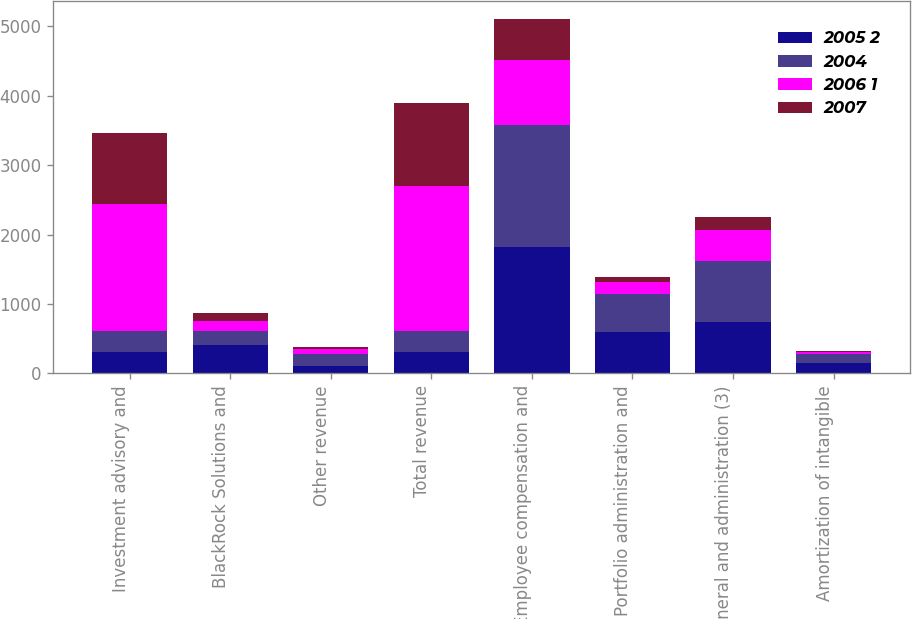Convert chart. <chart><loc_0><loc_0><loc_500><loc_500><stacked_bar_chart><ecel><fcel>Investment advisory and<fcel>BlackRock Solutions and<fcel>Other revenue<fcel>Total revenue<fcel>Employee compensation and<fcel>Portfolio administration and<fcel>General and administration (3)<fcel>Amortization of intangible<nl><fcel>2005 2<fcel>302<fcel>406<fcel>110<fcel>302<fcel>1815<fcel>597<fcel>745<fcel>146<nl><fcel>2004<fcel>302<fcel>198<fcel>164<fcel>302<fcel>1767<fcel>548<fcel>870<fcel>130<nl><fcel>2006 1<fcel>1841<fcel>148<fcel>73<fcel>2098<fcel>934<fcel>173<fcel>451<fcel>38<nl><fcel>2007<fcel>1018<fcel>124<fcel>38<fcel>1191<fcel>588<fcel>64<fcel>181<fcel>8<nl></chart> 